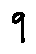<formula> <loc_0><loc_0><loc_500><loc_500>9</formula> 